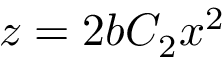Convert formula to latex. <formula><loc_0><loc_0><loc_500><loc_500>z = 2 b C _ { 2 } x ^ { 2 }</formula> 